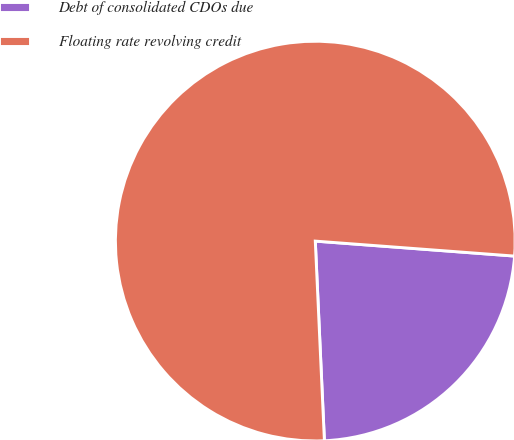Convert chart to OTSL. <chart><loc_0><loc_0><loc_500><loc_500><pie_chart><fcel>Debt of consolidated CDOs due<fcel>Floating rate revolving credit<nl><fcel>23.08%<fcel>76.92%<nl></chart> 